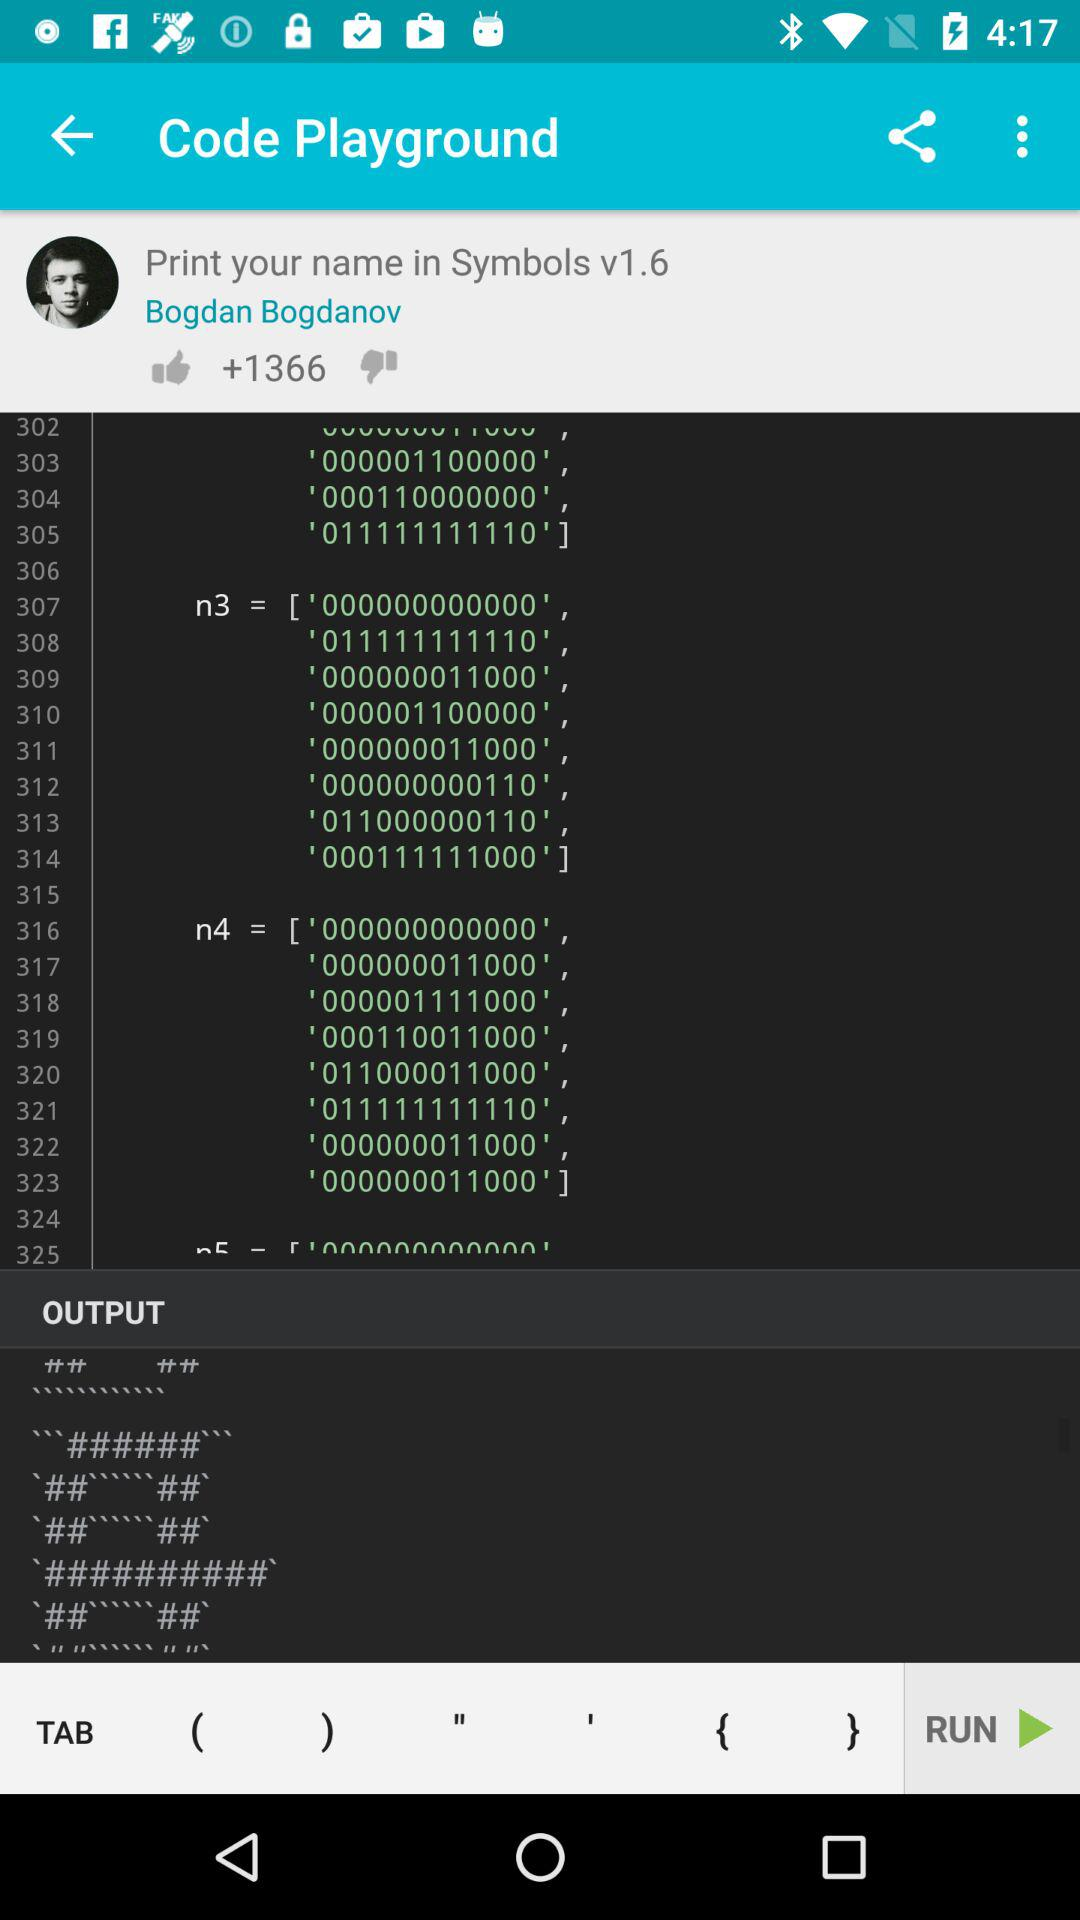What's the name of author? The name of author is Bogdan Bogdanov. 